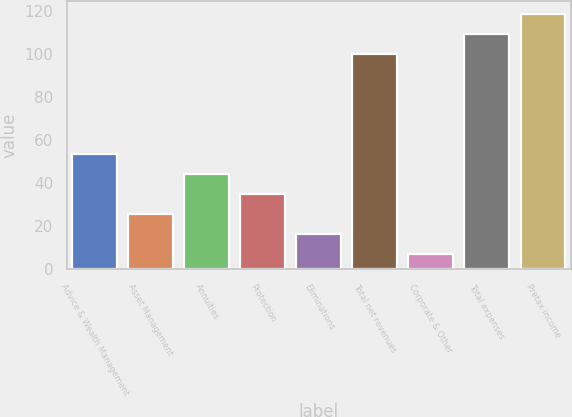Convert chart. <chart><loc_0><loc_0><loc_500><loc_500><bar_chart><fcel>Advice & Wealth Management<fcel>Asset Management<fcel>Annuities<fcel>Protection<fcel>Eliminations<fcel>Total net revenues<fcel>Corporate & Other<fcel>Total expenses<fcel>Pretax income<nl><fcel>53.5<fcel>25.6<fcel>44.2<fcel>34.9<fcel>16.3<fcel>100<fcel>7<fcel>109.3<fcel>118.6<nl></chart> 